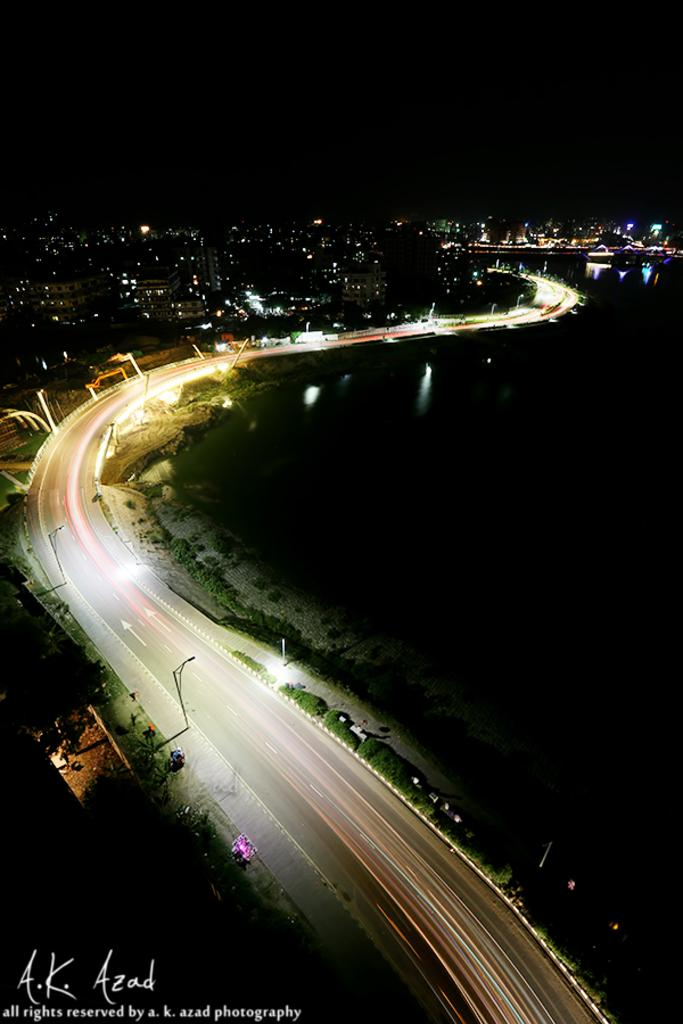What is the main feature of the image? There is a road in the image. What else can be seen along the road? There are poles, lights, trees, and buildings visible in the image. Can you describe the background of the image? The background of the image is dark. What is present on the right side of the image? There is water visible on the right side of the image. How many dimes are scattered around the nest in the image? There is no nest or dimes present in the image. 